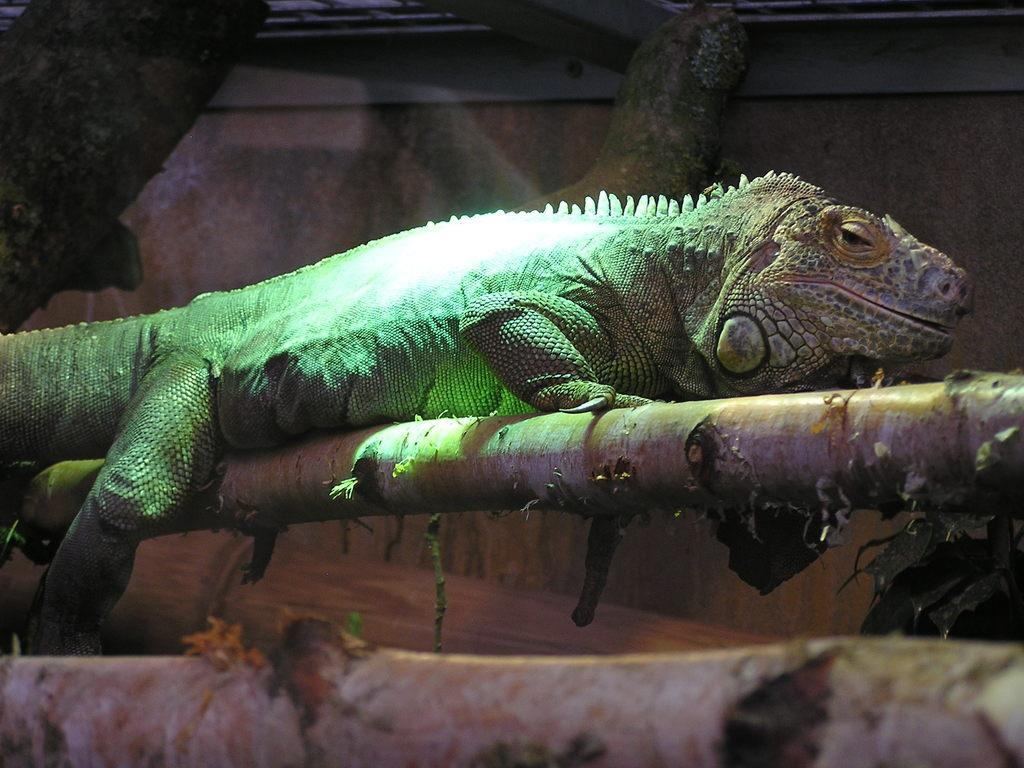What type of animal is in the image? There is a lizard in the image. Where is the lizard located? The lizard is on the branch of a tree. What can be seen in the background of the image? There is a wall in the background of the image. How many oranges are being held by the lizard's fork in the image? There are no oranges or forks present in the image; it features a lizard on a tree branch. 